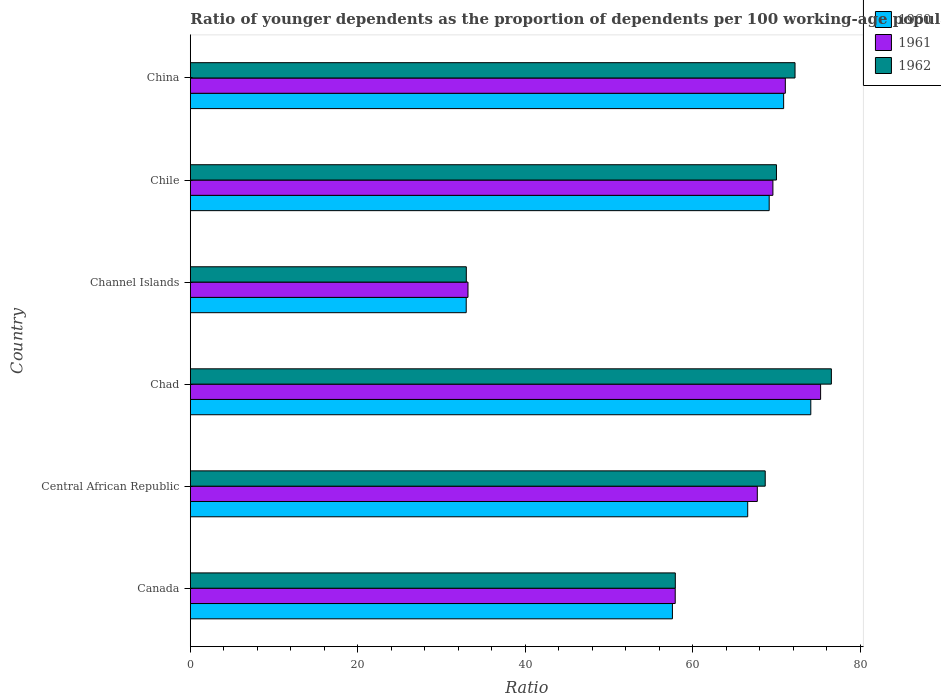How many groups of bars are there?
Provide a succinct answer. 6. Are the number of bars per tick equal to the number of legend labels?
Offer a terse response. Yes. How many bars are there on the 1st tick from the top?
Your answer should be compact. 3. In how many cases, is the number of bars for a given country not equal to the number of legend labels?
Provide a short and direct response. 0. What is the age dependency ratio(young) in 1960 in Chile?
Your answer should be very brief. 69.12. Across all countries, what is the maximum age dependency ratio(young) in 1961?
Keep it short and to the point. 75.27. Across all countries, what is the minimum age dependency ratio(young) in 1960?
Your response must be concise. 32.95. In which country was the age dependency ratio(young) in 1960 maximum?
Your response must be concise. Chad. In which country was the age dependency ratio(young) in 1960 minimum?
Provide a short and direct response. Channel Islands. What is the total age dependency ratio(young) in 1961 in the graph?
Your answer should be compact. 374.65. What is the difference between the age dependency ratio(young) in 1960 in Canada and that in Channel Islands?
Offer a terse response. 24.62. What is the difference between the age dependency ratio(young) in 1961 in Central African Republic and the age dependency ratio(young) in 1960 in Chad?
Offer a terse response. -6.39. What is the average age dependency ratio(young) in 1960 per country?
Your answer should be compact. 61.86. What is the difference between the age dependency ratio(young) in 1960 and age dependency ratio(young) in 1961 in Central African Republic?
Ensure brevity in your answer.  -1.15. In how many countries, is the age dependency ratio(young) in 1961 greater than 56 ?
Provide a succinct answer. 5. What is the ratio of the age dependency ratio(young) in 1960 in Channel Islands to that in China?
Provide a succinct answer. 0.47. What is the difference between the highest and the second highest age dependency ratio(young) in 1962?
Your answer should be very brief. 4.34. What is the difference between the highest and the lowest age dependency ratio(young) in 1960?
Your response must be concise. 41.15. In how many countries, is the age dependency ratio(young) in 1962 greater than the average age dependency ratio(young) in 1962 taken over all countries?
Keep it short and to the point. 4. Is the sum of the age dependency ratio(young) in 1961 in Channel Islands and China greater than the maximum age dependency ratio(young) in 1962 across all countries?
Your response must be concise. Yes. What does the 3rd bar from the top in Channel Islands represents?
Your response must be concise. 1960. What does the 3rd bar from the bottom in Chad represents?
Provide a short and direct response. 1962. How many bars are there?
Keep it short and to the point. 18. What is the difference between two consecutive major ticks on the X-axis?
Offer a terse response. 20. Are the values on the major ticks of X-axis written in scientific E-notation?
Keep it short and to the point. No. Does the graph contain any zero values?
Give a very brief answer. No. Where does the legend appear in the graph?
Provide a succinct answer. Top right. How many legend labels are there?
Make the answer very short. 3. What is the title of the graph?
Give a very brief answer. Ratio of younger dependents as the proportion of dependents per 100 working-age population. What is the label or title of the X-axis?
Offer a terse response. Ratio. What is the label or title of the Y-axis?
Your answer should be compact. Country. What is the Ratio of 1960 in Canada?
Make the answer very short. 57.57. What is the Ratio in 1961 in Canada?
Provide a succinct answer. 57.9. What is the Ratio in 1962 in Canada?
Provide a succinct answer. 57.91. What is the Ratio in 1960 in Central African Republic?
Ensure brevity in your answer.  66.56. What is the Ratio in 1961 in Central African Republic?
Provide a succinct answer. 67.71. What is the Ratio in 1962 in Central African Republic?
Ensure brevity in your answer.  68.65. What is the Ratio of 1960 in Chad?
Offer a very short reply. 74.09. What is the Ratio of 1961 in Chad?
Your answer should be very brief. 75.27. What is the Ratio in 1962 in Chad?
Provide a succinct answer. 76.55. What is the Ratio of 1960 in Channel Islands?
Keep it short and to the point. 32.95. What is the Ratio of 1961 in Channel Islands?
Make the answer very short. 33.16. What is the Ratio in 1962 in Channel Islands?
Keep it short and to the point. 32.96. What is the Ratio of 1960 in Chile?
Ensure brevity in your answer.  69.12. What is the Ratio of 1961 in Chile?
Give a very brief answer. 69.57. What is the Ratio of 1962 in Chile?
Make the answer very short. 69.99. What is the Ratio of 1960 in China?
Provide a short and direct response. 70.85. What is the Ratio of 1961 in China?
Provide a short and direct response. 71.05. What is the Ratio of 1962 in China?
Your answer should be compact. 72.21. Across all countries, what is the maximum Ratio of 1960?
Your response must be concise. 74.09. Across all countries, what is the maximum Ratio of 1961?
Offer a terse response. 75.27. Across all countries, what is the maximum Ratio in 1962?
Offer a terse response. 76.55. Across all countries, what is the minimum Ratio of 1960?
Provide a short and direct response. 32.95. Across all countries, what is the minimum Ratio in 1961?
Keep it short and to the point. 33.16. Across all countries, what is the minimum Ratio of 1962?
Ensure brevity in your answer.  32.96. What is the total Ratio in 1960 in the graph?
Keep it short and to the point. 371.14. What is the total Ratio in 1961 in the graph?
Make the answer very short. 374.65. What is the total Ratio of 1962 in the graph?
Your answer should be very brief. 378.28. What is the difference between the Ratio of 1960 in Canada and that in Central African Republic?
Keep it short and to the point. -8.99. What is the difference between the Ratio in 1961 in Canada and that in Central African Republic?
Your answer should be compact. -9.8. What is the difference between the Ratio of 1962 in Canada and that in Central African Republic?
Ensure brevity in your answer.  -10.74. What is the difference between the Ratio of 1960 in Canada and that in Chad?
Keep it short and to the point. -16.52. What is the difference between the Ratio of 1961 in Canada and that in Chad?
Your response must be concise. -17.36. What is the difference between the Ratio of 1962 in Canada and that in Chad?
Your answer should be very brief. -18.64. What is the difference between the Ratio of 1960 in Canada and that in Channel Islands?
Provide a short and direct response. 24.62. What is the difference between the Ratio of 1961 in Canada and that in Channel Islands?
Your answer should be compact. 24.75. What is the difference between the Ratio of 1962 in Canada and that in Channel Islands?
Your response must be concise. 24.96. What is the difference between the Ratio in 1960 in Canada and that in Chile?
Your response must be concise. -11.56. What is the difference between the Ratio in 1961 in Canada and that in Chile?
Provide a short and direct response. -11.66. What is the difference between the Ratio in 1962 in Canada and that in Chile?
Offer a terse response. -12.08. What is the difference between the Ratio of 1960 in Canada and that in China?
Offer a terse response. -13.28. What is the difference between the Ratio of 1961 in Canada and that in China?
Give a very brief answer. -13.15. What is the difference between the Ratio in 1962 in Canada and that in China?
Keep it short and to the point. -14.29. What is the difference between the Ratio of 1960 in Central African Republic and that in Chad?
Provide a short and direct response. -7.54. What is the difference between the Ratio of 1961 in Central African Republic and that in Chad?
Provide a succinct answer. -7.56. What is the difference between the Ratio of 1962 in Central African Republic and that in Chad?
Offer a very short reply. -7.9. What is the difference between the Ratio in 1960 in Central African Republic and that in Channel Islands?
Provide a succinct answer. 33.61. What is the difference between the Ratio in 1961 in Central African Republic and that in Channel Islands?
Your answer should be very brief. 34.55. What is the difference between the Ratio in 1962 in Central African Republic and that in Channel Islands?
Offer a terse response. 35.69. What is the difference between the Ratio in 1960 in Central African Republic and that in Chile?
Provide a succinct answer. -2.57. What is the difference between the Ratio in 1961 in Central African Republic and that in Chile?
Keep it short and to the point. -1.86. What is the difference between the Ratio in 1962 in Central African Republic and that in Chile?
Your answer should be compact. -1.34. What is the difference between the Ratio in 1960 in Central African Republic and that in China?
Make the answer very short. -4.29. What is the difference between the Ratio of 1961 in Central African Republic and that in China?
Provide a succinct answer. -3.35. What is the difference between the Ratio in 1962 in Central African Republic and that in China?
Your answer should be very brief. -3.56. What is the difference between the Ratio in 1960 in Chad and that in Channel Islands?
Keep it short and to the point. 41.15. What is the difference between the Ratio of 1961 in Chad and that in Channel Islands?
Offer a very short reply. 42.11. What is the difference between the Ratio in 1962 in Chad and that in Channel Islands?
Ensure brevity in your answer.  43.59. What is the difference between the Ratio in 1960 in Chad and that in Chile?
Ensure brevity in your answer.  4.97. What is the difference between the Ratio of 1961 in Chad and that in Chile?
Ensure brevity in your answer.  5.7. What is the difference between the Ratio in 1962 in Chad and that in Chile?
Your answer should be compact. 6.56. What is the difference between the Ratio in 1960 in Chad and that in China?
Ensure brevity in your answer.  3.24. What is the difference between the Ratio of 1961 in Chad and that in China?
Offer a very short reply. 4.21. What is the difference between the Ratio of 1962 in Chad and that in China?
Provide a short and direct response. 4.34. What is the difference between the Ratio in 1960 in Channel Islands and that in Chile?
Offer a very short reply. -36.18. What is the difference between the Ratio of 1961 in Channel Islands and that in Chile?
Offer a terse response. -36.41. What is the difference between the Ratio of 1962 in Channel Islands and that in Chile?
Offer a very short reply. -37.03. What is the difference between the Ratio in 1960 in Channel Islands and that in China?
Make the answer very short. -37.9. What is the difference between the Ratio of 1961 in Channel Islands and that in China?
Keep it short and to the point. -37.89. What is the difference between the Ratio in 1962 in Channel Islands and that in China?
Make the answer very short. -39.25. What is the difference between the Ratio of 1960 in Chile and that in China?
Your response must be concise. -1.73. What is the difference between the Ratio in 1961 in Chile and that in China?
Ensure brevity in your answer.  -1.48. What is the difference between the Ratio in 1962 in Chile and that in China?
Keep it short and to the point. -2.22. What is the difference between the Ratio in 1960 in Canada and the Ratio in 1961 in Central African Republic?
Make the answer very short. -10.14. What is the difference between the Ratio of 1960 in Canada and the Ratio of 1962 in Central African Republic?
Give a very brief answer. -11.08. What is the difference between the Ratio in 1961 in Canada and the Ratio in 1962 in Central African Republic?
Provide a succinct answer. -10.75. What is the difference between the Ratio of 1960 in Canada and the Ratio of 1961 in Chad?
Keep it short and to the point. -17.7. What is the difference between the Ratio in 1960 in Canada and the Ratio in 1962 in Chad?
Keep it short and to the point. -18.98. What is the difference between the Ratio of 1961 in Canada and the Ratio of 1962 in Chad?
Provide a short and direct response. -18.65. What is the difference between the Ratio of 1960 in Canada and the Ratio of 1961 in Channel Islands?
Provide a short and direct response. 24.41. What is the difference between the Ratio of 1960 in Canada and the Ratio of 1962 in Channel Islands?
Your answer should be compact. 24.61. What is the difference between the Ratio in 1961 in Canada and the Ratio in 1962 in Channel Islands?
Your answer should be very brief. 24.95. What is the difference between the Ratio of 1960 in Canada and the Ratio of 1961 in Chile?
Make the answer very short. -12. What is the difference between the Ratio of 1960 in Canada and the Ratio of 1962 in Chile?
Your answer should be compact. -12.42. What is the difference between the Ratio in 1961 in Canada and the Ratio in 1962 in Chile?
Make the answer very short. -12.09. What is the difference between the Ratio in 1960 in Canada and the Ratio in 1961 in China?
Offer a very short reply. -13.48. What is the difference between the Ratio in 1960 in Canada and the Ratio in 1962 in China?
Offer a terse response. -14.64. What is the difference between the Ratio of 1961 in Canada and the Ratio of 1962 in China?
Offer a terse response. -14.31. What is the difference between the Ratio of 1960 in Central African Republic and the Ratio of 1961 in Chad?
Provide a short and direct response. -8.71. What is the difference between the Ratio in 1960 in Central African Republic and the Ratio in 1962 in Chad?
Ensure brevity in your answer.  -9.99. What is the difference between the Ratio of 1961 in Central African Republic and the Ratio of 1962 in Chad?
Provide a succinct answer. -8.84. What is the difference between the Ratio of 1960 in Central African Republic and the Ratio of 1961 in Channel Islands?
Ensure brevity in your answer.  33.4. What is the difference between the Ratio in 1960 in Central African Republic and the Ratio in 1962 in Channel Islands?
Give a very brief answer. 33.6. What is the difference between the Ratio in 1961 in Central African Republic and the Ratio in 1962 in Channel Islands?
Your answer should be compact. 34.75. What is the difference between the Ratio of 1960 in Central African Republic and the Ratio of 1961 in Chile?
Give a very brief answer. -3.01. What is the difference between the Ratio of 1960 in Central African Republic and the Ratio of 1962 in Chile?
Keep it short and to the point. -3.43. What is the difference between the Ratio in 1961 in Central African Republic and the Ratio in 1962 in Chile?
Ensure brevity in your answer.  -2.29. What is the difference between the Ratio of 1960 in Central African Republic and the Ratio of 1961 in China?
Provide a short and direct response. -4.49. What is the difference between the Ratio of 1960 in Central African Republic and the Ratio of 1962 in China?
Give a very brief answer. -5.65. What is the difference between the Ratio of 1961 in Central African Republic and the Ratio of 1962 in China?
Provide a succinct answer. -4.5. What is the difference between the Ratio in 1960 in Chad and the Ratio in 1961 in Channel Islands?
Offer a terse response. 40.94. What is the difference between the Ratio of 1960 in Chad and the Ratio of 1962 in Channel Islands?
Keep it short and to the point. 41.14. What is the difference between the Ratio of 1961 in Chad and the Ratio of 1962 in Channel Islands?
Give a very brief answer. 42.31. What is the difference between the Ratio of 1960 in Chad and the Ratio of 1961 in Chile?
Keep it short and to the point. 4.53. What is the difference between the Ratio in 1960 in Chad and the Ratio in 1962 in Chile?
Your answer should be very brief. 4.1. What is the difference between the Ratio in 1961 in Chad and the Ratio in 1962 in Chile?
Your answer should be very brief. 5.27. What is the difference between the Ratio in 1960 in Chad and the Ratio in 1961 in China?
Provide a short and direct response. 3.04. What is the difference between the Ratio of 1960 in Chad and the Ratio of 1962 in China?
Provide a succinct answer. 1.88. What is the difference between the Ratio of 1961 in Chad and the Ratio of 1962 in China?
Ensure brevity in your answer.  3.06. What is the difference between the Ratio of 1960 in Channel Islands and the Ratio of 1961 in Chile?
Keep it short and to the point. -36.62. What is the difference between the Ratio in 1960 in Channel Islands and the Ratio in 1962 in Chile?
Offer a terse response. -37.05. What is the difference between the Ratio of 1961 in Channel Islands and the Ratio of 1962 in Chile?
Make the answer very short. -36.83. What is the difference between the Ratio of 1960 in Channel Islands and the Ratio of 1961 in China?
Offer a terse response. -38.11. What is the difference between the Ratio in 1960 in Channel Islands and the Ratio in 1962 in China?
Offer a terse response. -39.26. What is the difference between the Ratio in 1961 in Channel Islands and the Ratio in 1962 in China?
Make the answer very short. -39.05. What is the difference between the Ratio of 1960 in Chile and the Ratio of 1961 in China?
Offer a terse response. -1.93. What is the difference between the Ratio of 1960 in Chile and the Ratio of 1962 in China?
Ensure brevity in your answer.  -3.09. What is the difference between the Ratio of 1961 in Chile and the Ratio of 1962 in China?
Provide a short and direct response. -2.64. What is the average Ratio in 1960 per country?
Offer a very short reply. 61.86. What is the average Ratio of 1961 per country?
Provide a succinct answer. 62.44. What is the average Ratio of 1962 per country?
Your response must be concise. 63.05. What is the difference between the Ratio of 1960 and Ratio of 1961 in Canada?
Give a very brief answer. -0.34. What is the difference between the Ratio in 1960 and Ratio in 1962 in Canada?
Offer a terse response. -0.35. What is the difference between the Ratio of 1961 and Ratio of 1962 in Canada?
Your answer should be compact. -0.01. What is the difference between the Ratio in 1960 and Ratio in 1961 in Central African Republic?
Offer a very short reply. -1.15. What is the difference between the Ratio in 1960 and Ratio in 1962 in Central African Republic?
Keep it short and to the point. -2.09. What is the difference between the Ratio of 1961 and Ratio of 1962 in Central African Republic?
Offer a very short reply. -0.94. What is the difference between the Ratio in 1960 and Ratio in 1961 in Chad?
Your answer should be compact. -1.17. What is the difference between the Ratio in 1960 and Ratio in 1962 in Chad?
Ensure brevity in your answer.  -2.46. What is the difference between the Ratio in 1961 and Ratio in 1962 in Chad?
Your response must be concise. -1.28. What is the difference between the Ratio in 1960 and Ratio in 1961 in Channel Islands?
Give a very brief answer. -0.21. What is the difference between the Ratio of 1960 and Ratio of 1962 in Channel Islands?
Your answer should be compact. -0.01. What is the difference between the Ratio of 1960 and Ratio of 1961 in Chile?
Offer a very short reply. -0.44. What is the difference between the Ratio of 1960 and Ratio of 1962 in Chile?
Provide a succinct answer. -0.87. What is the difference between the Ratio in 1961 and Ratio in 1962 in Chile?
Ensure brevity in your answer.  -0.42. What is the difference between the Ratio in 1960 and Ratio in 1961 in China?
Offer a terse response. -0.2. What is the difference between the Ratio of 1960 and Ratio of 1962 in China?
Offer a terse response. -1.36. What is the difference between the Ratio in 1961 and Ratio in 1962 in China?
Offer a terse response. -1.16. What is the ratio of the Ratio of 1960 in Canada to that in Central African Republic?
Keep it short and to the point. 0.86. What is the ratio of the Ratio of 1961 in Canada to that in Central African Republic?
Offer a terse response. 0.86. What is the ratio of the Ratio in 1962 in Canada to that in Central African Republic?
Your answer should be very brief. 0.84. What is the ratio of the Ratio in 1960 in Canada to that in Chad?
Provide a short and direct response. 0.78. What is the ratio of the Ratio of 1961 in Canada to that in Chad?
Your response must be concise. 0.77. What is the ratio of the Ratio in 1962 in Canada to that in Chad?
Your answer should be very brief. 0.76. What is the ratio of the Ratio in 1960 in Canada to that in Channel Islands?
Give a very brief answer. 1.75. What is the ratio of the Ratio in 1961 in Canada to that in Channel Islands?
Your answer should be compact. 1.75. What is the ratio of the Ratio of 1962 in Canada to that in Channel Islands?
Give a very brief answer. 1.76. What is the ratio of the Ratio in 1960 in Canada to that in Chile?
Give a very brief answer. 0.83. What is the ratio of the Ratio in 1961 in Canada to that in Chile?
Ensure brevity in your answer.  0.83. What is the ratio of the Ratio in 1962 in Canada to that in Chile?
Give a very brief answer. 0.83. What is the ratio of the Ratio in 1960 in Canada to that in China?
Your answer should be very brief. 0.81. What is the ratio of the Ratio in 1961 in Canada to that in China?
Your answer should be very brief. 0.81. What is the ratio of the Ratio of 1962 in Canada to that in China?
Your response must be concise. 0.8. What is the ratio of the Ratio in 1960 in Central African Republic to that in Chad?
Provide a short and direct response. 0.9. What is the ratio of the Ratio of 1961 in Central African Republic to that in Chad?
Offer a terse response. 0.9. What is the ratio of the Ratio in 1962 in Central African Republic to that in Chad?
Make the answer very short. 0.9. What is the ratio of the Ratio of 1960 in Central African Republic to that in Channel Islands?
Your answer should be compact. 2.02. What is the ratio of the Ratio in 1961 in Central African Republic to that in Channel Islands?
Keep it short and to the point. 2.04. What is the ratio of the Ratio of 1962 in Central African Republic to that in Channel Islands?
Your answer should be compact. 2.08. What is the ratio of the Ratio of 1960 in Central African Republic to that in Chile?
Provide a short and direct response. 0.96. What is the ratio of the Ratio in 1961 in Central African Republic to that in Chile?
Keep it short and to the point. 0.97. What is the ratio of the Ratio of 1962 in Central African Republic to that in Chile?
Provide a short and direct response. 0.98. What is the ratio of the Ratio in 1960 in Central African Republic to that in China?
Make the answer very short. 0.94. What is the ratio of the Ratio in 1961 in Central African Republic to that in China?
Keep it short and to the point. 0.95. What is the ratio of the Ratio of 1962 in Central African Republic to that in China?
Provide a short and direct response. 0.95. What is the ratio of the Ratio of 1960 in Chad to that in Channel Islands?
Your answer should be very brief. 2.25. What is the ratio of the Ratio in 1961 in Chad to that in Channel Islands?
Make the answer very short. 2.27. What is the ratio of the Ratio in 1962 in Chad to that in Channel Islands?
Your response must be concise. 2.32. What is the ratio of the Ratio of 1960 in Chad to that in Chile?
Give a very brief answer. 1.07. What is the ratio of the Ratio in 1961 in Chad to that in Chile?
Give a very brief answer. 1.08. What is the ratio of the Ratio of 1962 in Chad to that in Chile?
Ensure brevity in your answer.  1.09. What is the ratio of the Ratio of 1960 in Chad to that in China?
Keep it short and to the point. 1.05. What is the ratio of the Ratio of 1961 in Chad to that in China?
Ensure brevity in your answer.  1.06. What is the ratio of the Ratio in 1962 in Chad to that in China?
Provide a short and direct response. 1.06. What is the ratio of the Ratio in 1960 in Channel Islands to that in Chile?
Your response must be concise. 0.48. What is the ratio of the Ratio of 1961 in Channel Islands to that in Chile?
Make the answer very short. 0.48. What is the ratio of the Ratio of 1962 in Channel Islands to that in Chile?
Your response must be concise. 0.47. What is the ratio of the Ratio of 1960 in Channel Islands to that in China?
Make the answer very short. 0.47. What is the ratio of the Ratio in 1961 in Channel Islands to that in China?
Offer a terse response. 0.47. What is the ratio of the Ratio of 1962 in Channel Islands to that in China?
Offer a very short reply. 0.46. What is the ratio of the Ratio in 1960 in Chile to that in China?
Your response must be concise. 0.98. What is the ratio of the Ratio in 1961 in Chile to that in China?
Provide a short and direct response. 0.98. What is the ratio of the Ratio in 1962 in Chile to that in China?
Provide a succinct answer. 0.97. What is the difference between the highest and the second highest Ratio in 1960?
Provide a short and direct response. 3.24. What is the difference between the highest and the second highest Ratio in 1961?
Make the answer very short. 4.21. What is the difference between the highest and the second highest Ratio in 1962?
Your answer should be compact. 4.34. What is the difference between the highest and the lowest Ratio in 1960?
Your answer should be very brief. 41.15. What is the difference between the highest and the lowest Ratio in 1961?
Your response must be concise. 42.11. What is the difference between the highest and the lowest Ratio of 1962?
Keep it short and to the point. 43.59. 